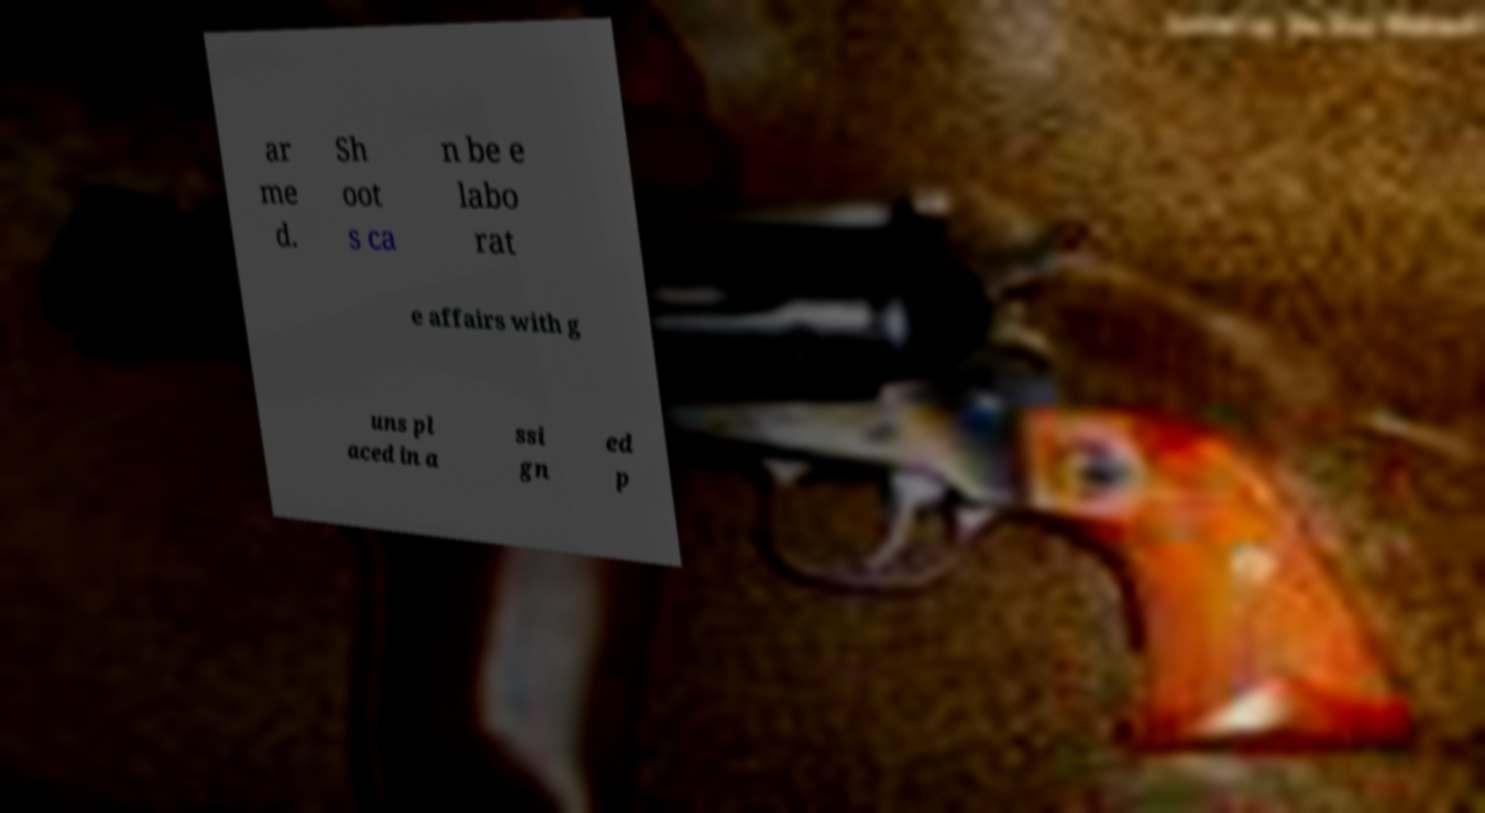Could you assist in decoding the text presented in this image and type it out clearly? ar me d. Sh oot s ca n be e labo rat e affairs with g uns pl aced in a ssi gn ed p 